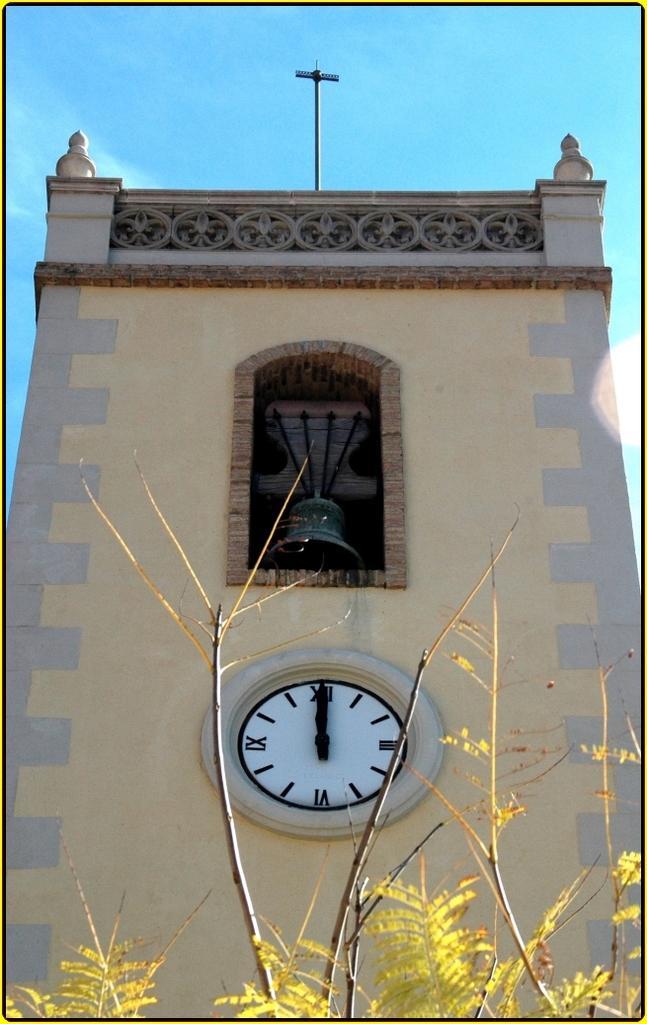Describe this image in one or two sentences. In this image there is a building and clock wall is placed on it. At front there are trees and at the background there is sky. 